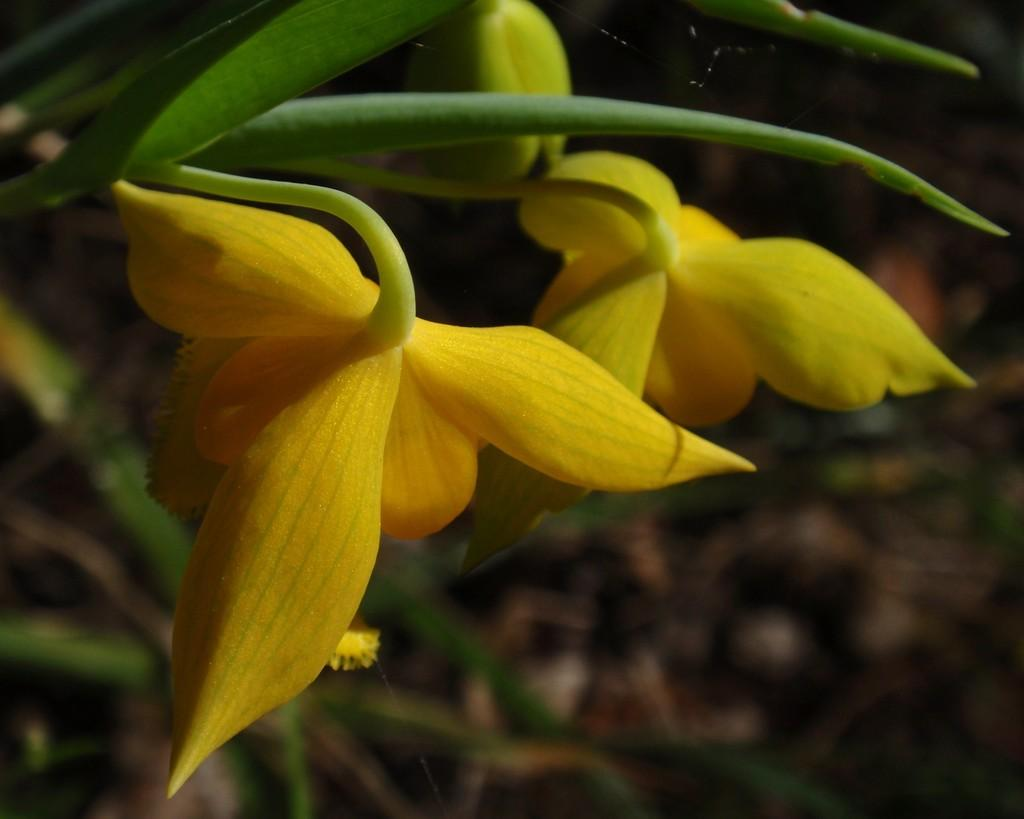What type of plant is shown in the image? The image shows a plant with flowers. What other features can be seen on the plant? There are leaves visible at the top of the plant in the image. What type of alarm is attached to the plant in the image? There is no alarm present in the image; it only shows a plant with flowers and leaves. 